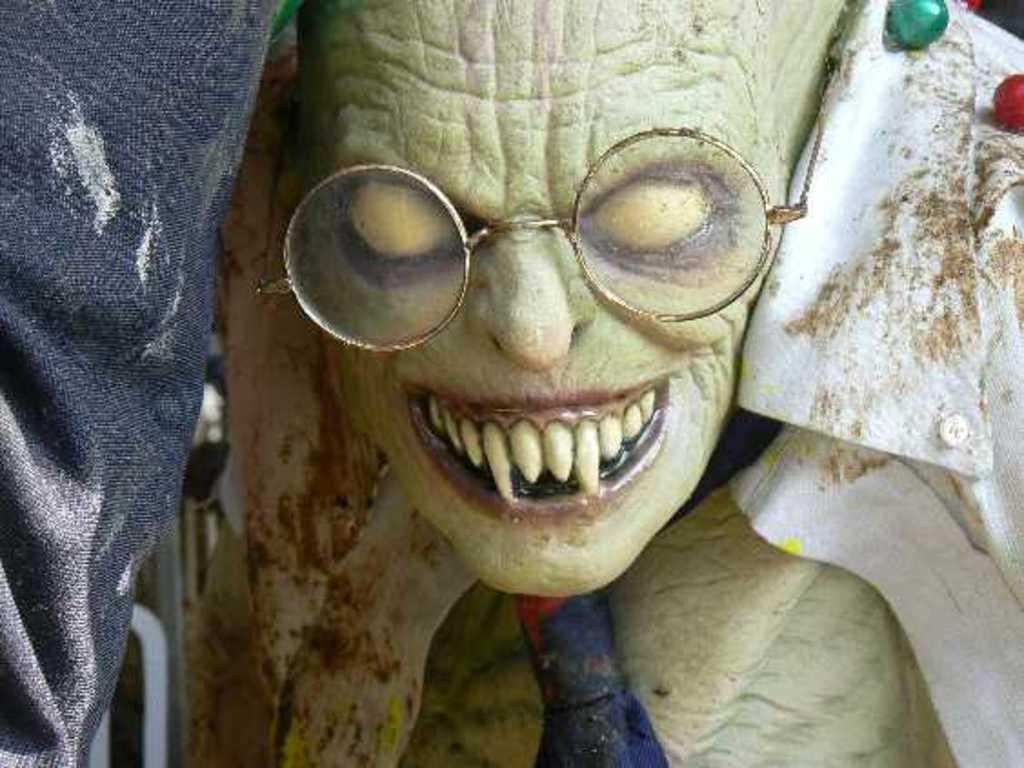What is the main subject of the image? The main subject of the image is a statue of the devil. What is the statue of the devil wearing? The statue of the devil is wearing spectacles. What color is the cloth visible in the image? The cloth in the image is grey. How does the growth of the plant affect the thunder in the image? There is no plant or thunder present in the image; it features a statue of the devil wearing spectacles and a grey cloth. 